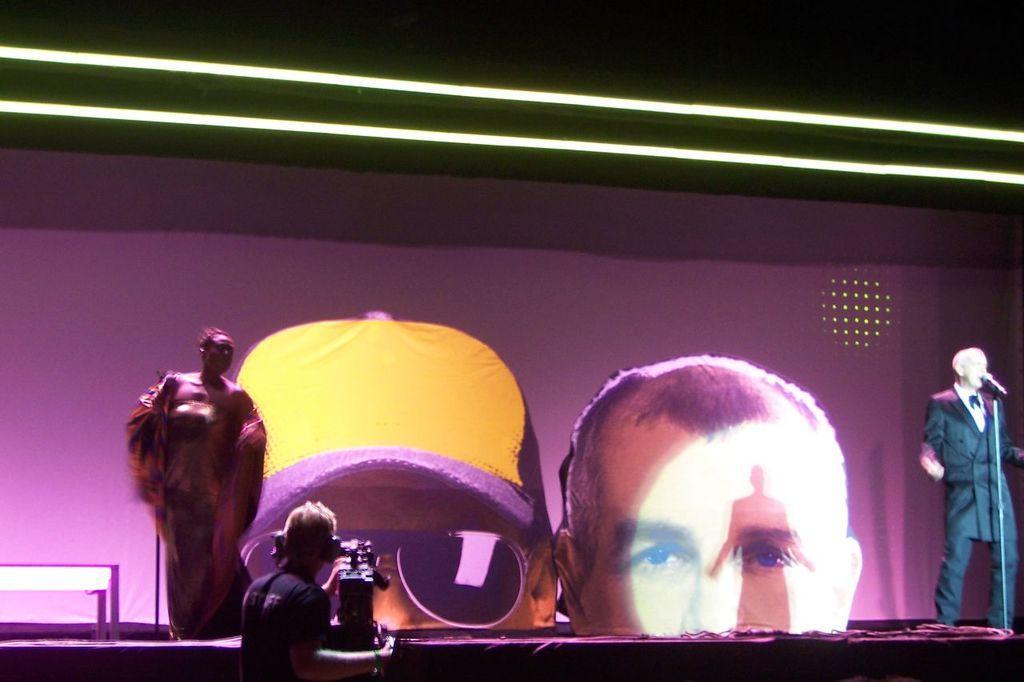Can you describe this image briefly? In the image there is an old man in suit talking on mic on the right side and another man standing on the left side on stage and in middle there is a man shooting in camera, in the background there is screen. 